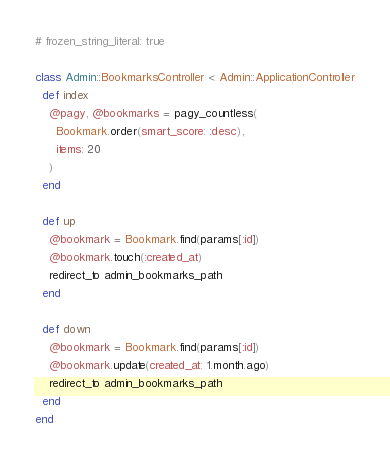Convert code to text. <code><loc_0><loc_0><loc_500><loc_500><_Ruby_># frozen_string_literal: true

class Admin::BookmarksController < Admin::ApplicationController
  def index
    @pagy, @bookmarks = pagy_countless(
      Bookmark.order(smart_score: :desc),
      items: 20
    )
  end

  def up
    @bookmark = Bookmark.find(params[:id])
    @bookmark.touch(:created_at)
    redirect_to admin_bookmarks_path
  end

  def down
    @bookmark = Bookmark.find(params[:id])
    @bookmark.update(created_at: 1.month.ago)
    redirect_to admin_bookmarks_path
  end
end
</code> 